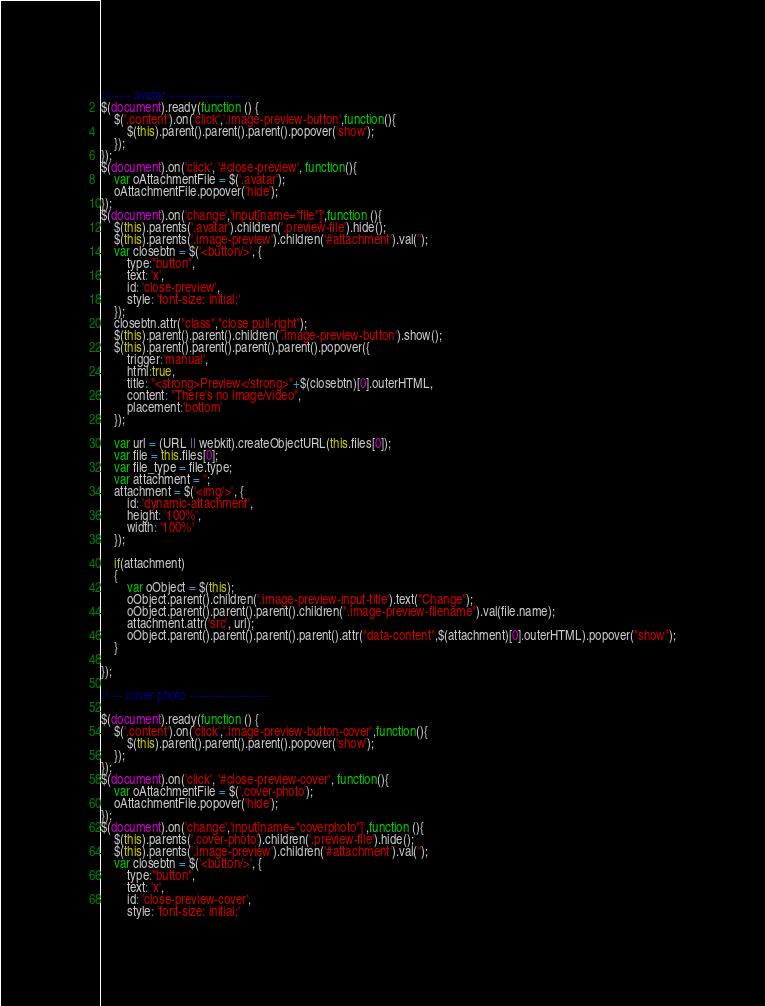Convert code to text. <code><loc_0><loc_0><loc_500><loc_500><_JavaScript_>//------ avatar --------------------
$(document).ready(function () {
    $('.content').on('click','.image-preview-button',function(){
        $(this).parent().parent().parent().popover('show');
    });
});
$(document).on('click', '#close-preview', function(){
    var oAttachmentFile = $('.avatar');
    oAttachmentFile.popover('hide');
});
$(document).on('change','input[name="file"]',function (){
    $(this).parents('.avatar').children('.preview-file').hide();
    $(this).parents('.image-preview').children('#attachment').val('');
    var closebtn = $('<button/>', {
        type:"button",
        text: 'x',
        id: 'close-preview',
        style: 'font-size: initial;'
    });
    closebtn.attr("class","close pull-right");
    $(this).parent().parent().children('.image-preview-button').show();
    $(this).parent().parent().parent().parent().popover({
        trigger:'manual',
        html:true,
        title: "<strong>Preview</strong>"+$(closebtn)[0].outerHTML,
        content: "There's no image/video",
        placement:'bottom'
    });
    
    var url = (URL || webkit).createObjectURL(this.files[0]);
    var file = this.files[0];
    var file_type = file.type;
    var attachment = '';
    attachment = $('<img/>', {
        id: 'dynamic-attachment',
        height: '100%',
        width: '100%'
    });

    if(attachment)
    {
        var oObject = $(this);
        oObject.parent().children('.image-preview-input-title').text("Change");
        oObject.parent().parent().parent().children(".image-preview-filename").val(file.name);
        attachment.attr('src', url);
        oObject.parent().parent().parent().parent().attr("data-content",$(attachment)[0].outerHTML).popover("show");
    }

});

//---- cover photo ---------------------

$(document).ready(function () {
    $('.content').on('click','.image-preview-button-cover',function(){
        $(this).parent().parent().parent().popover('show');
    });
});
$(document).on('click', '#close-preview-cover', function(){
    var oAttachmentFile = $('.cover-photo');
    oAttachmentFile.popover('hide');
});
$(document).on('change','input[name="coverphoto"]',function (){
    $(this).parents('.cover-photo').children('.preview-file').hide();
    $(this).parents('.image-preview').children('#attachment').val('');
    var closebtn = $('<button/>', {
        type:"button",
        text: 'x',
        id: 'close-preview-cover',
        style: 'font-size: initial;'</code> 